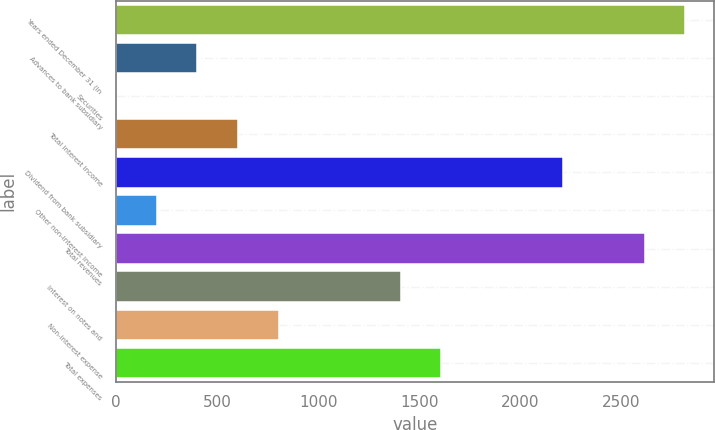Convert chart to OTSL. <chart><loc_0><loc_0><loc_500><loc_500><bar_chart><fcel>Years ended December 31 (in<fcel>Advances to bank subsidiary<fcel>Securities<fcel>Total interest income<fcel>Dividend from bank subsidiary<fcel>Other non-interest income<fcel>Total revenues<fcel>Interest on notes and<fcel>Non-interest expense<fcel>Total expenses<nl><fcel>2818.08<fcel>402.84<fcel>0.3<fcel>604.11<fcel>2214.27<fcel>201.57<fcel>2616.81<fcel>1409.19<fcel>805.38<fcel>1610.46<nl></chart> 